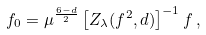Convert formula to latex. <formula><loc_0><loc_0><loc_500><loc_500>f _ { 0 } = \mu ^ { \frac { 6 - d } { 2 } } \, { \left [ Z _ { \lambda } ( f ^ { 2 } , d ) \right ] } ^ { - 1 } \, f \, ,</formula> 